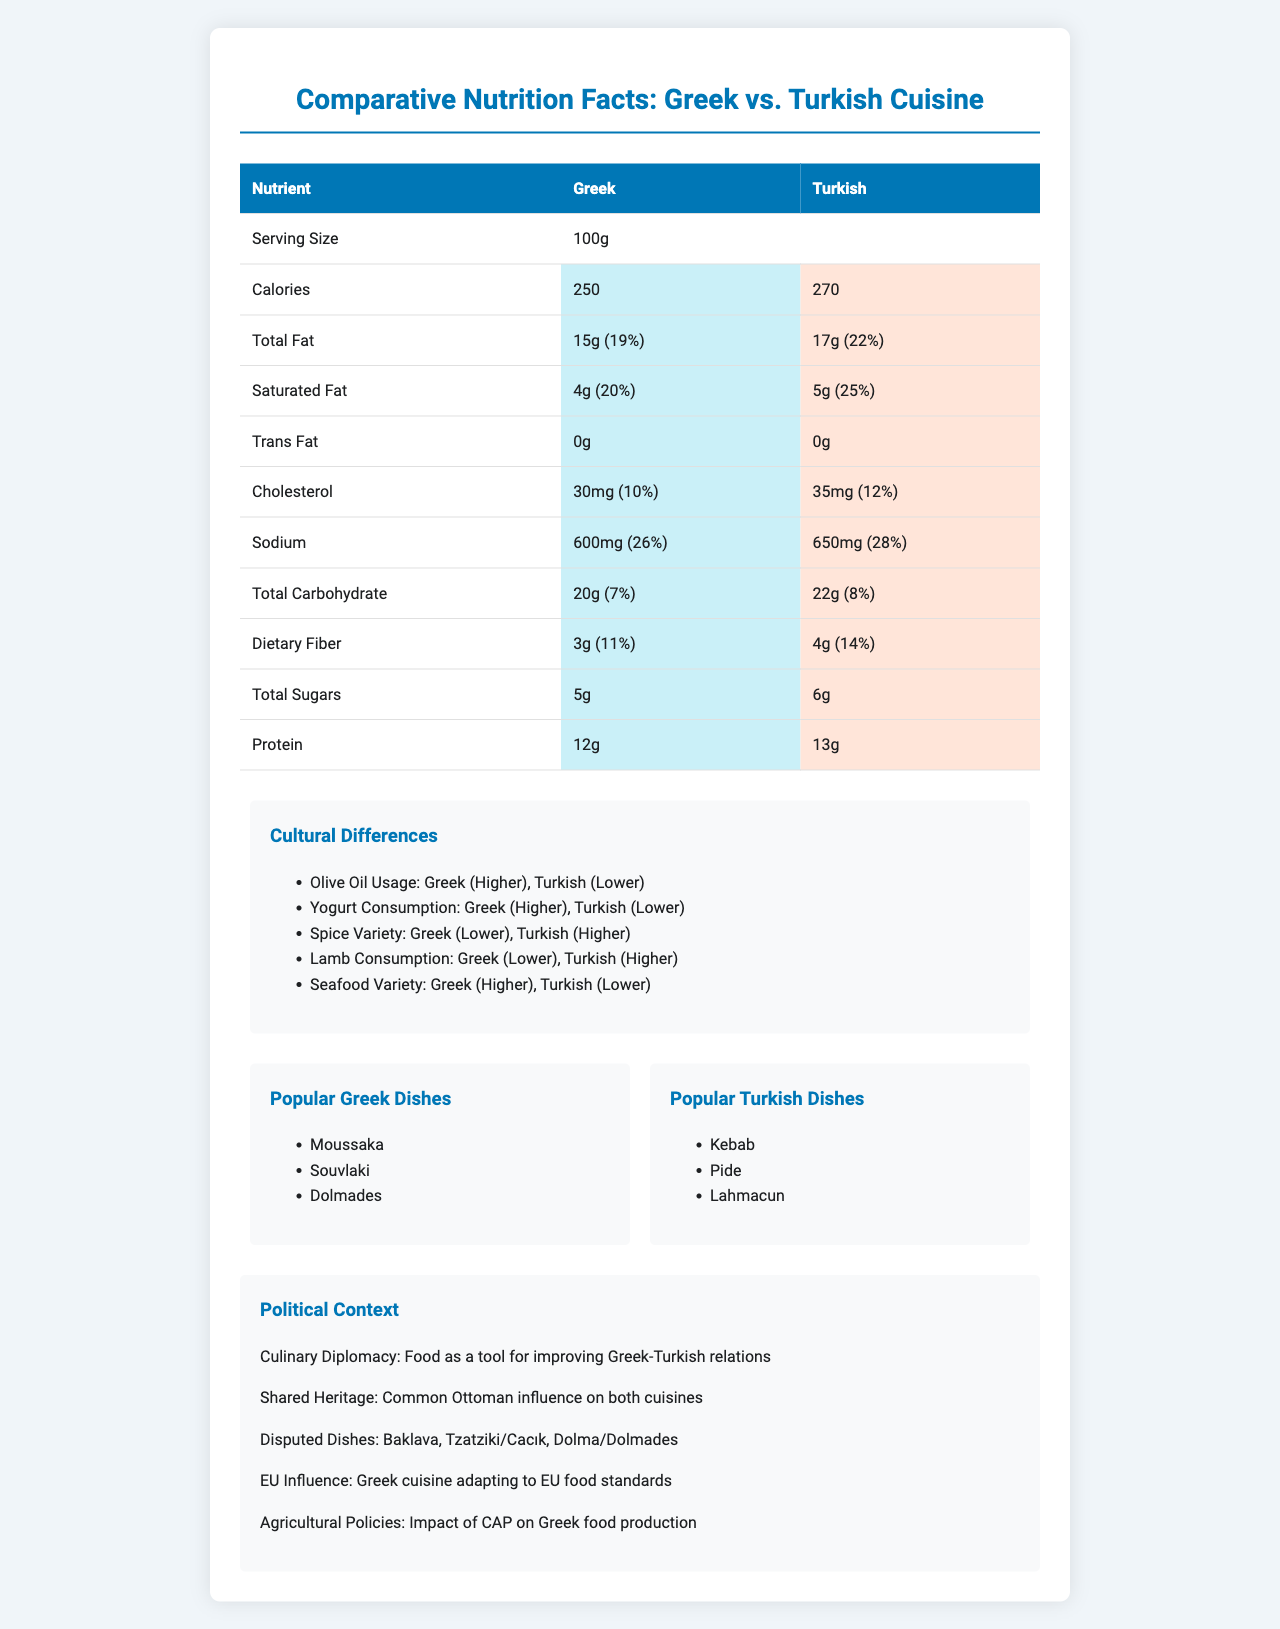What is the serving size mentioned for both cuisines? The serving size is stated as 100g for both Greek and Turkish cuisines.
Answer: 100g How many calories are there in a serving of Greek cuisine according to the document? The document states that Greek cuisine has 250 calories per serving.
Answer: 250 Compare the total fat content in Greek and Turkish cuisines. Which has more? Turkish cuisine has 17g of total fat while Greek cuisine has 15g of total fat.
Answer: Turkish cuisine What is the percent daily value of sodium in Turkish cuisine? The percent daily value of sodium in Turkish cuisine is listed as 28%.
Answer: 28% Which cuisine has a higher dietary fiber content? Turkish cuisine has 4g of dietary fiber, while Greek cuisine has 3g.
Answer: Turkish cuisine Which nutrient is listed with a higher percentage daily value in Greek cuisine compared to Turkish cuisine? A. Cholesterol B. Calcium C. Iron D. Vitamin D Greek cuisine has a 12% daily value for calcium, whereas Turkish cuisine has 11%.
Answer: Calcium Which cuisine has a higher protein content? Turkish cuisine contains 13g of protein, compared to 12g in Greek cuisine.
Answer: Turkish cuisine Does Greek or Turkish cuisine have a higher variety of seafood? The document mentions that Greek cuisine has a higher variety of seafood compared to Turkish cuisine.
Answer: Greek cuisine Is there any mention of trans fats in the document? Both Greek and Turkish cuisines have 0g trans fats according to the document.
Answer: Yes Summarize the main idea of the document. The document gives detailed nutritional information such as calories, fats, cholesterol, and more for both cuisines per 100g serving. It also delves into cultural differences like olive oil usage and spice variety, lists popular dishes, and discusses the political context regarding culinary diplomacy and shared heritage.
Answer: The document provides a comparative analysis of the nutritional facts of Greek and Turkish cuisines, highlighting differences in nutrient content, cultural food practices, and political context related to the culinary traditions of both nations. Which cuisine uses more olive oil according to the document? A. Greek B. Turkish C. Both use the same amount The document states that Greek cuisine has higher olive oil usage compared to Turkish cuisine.
Answer: A. Greek List three popular dishes from Greek cuisine as mentioned in the document. The document lists Moussaka, Souvlaki, and Dolmades as popular Greek dishes.
Answer: Moussaka, Souvlaki, Dolmades Does the document mention any shared heritage between Greek and Turkish cuisines? The document states that there is a common Ottoman influence on both Greek and Turkish cuisines.
Answer: Yes Is the impact of the Common Agricultural Policy (CAP) on Greek food production discussed in the document? The document mentions the impact of CAP on Greek food production.
Answer: Yes Which cuisine has a higher cholesterol content? The document states that Turkish cuisine has 35mg of cholesterol, while Greek cuisine has 30mg.
Answer: Turkish cuisine What is the main goal of culinary diplomacy mentioned in the document? The document explains that culinary diplomacy aims to use food as a means to improve Greek-Turkish relations.
Answer: Food as a tool for improving Greek-Turkish relations Are the exact cooking methods for the dishes mentioned? The document does not provide specific details on the cooking methods for the listed dishes.
Answer: Not enough information 